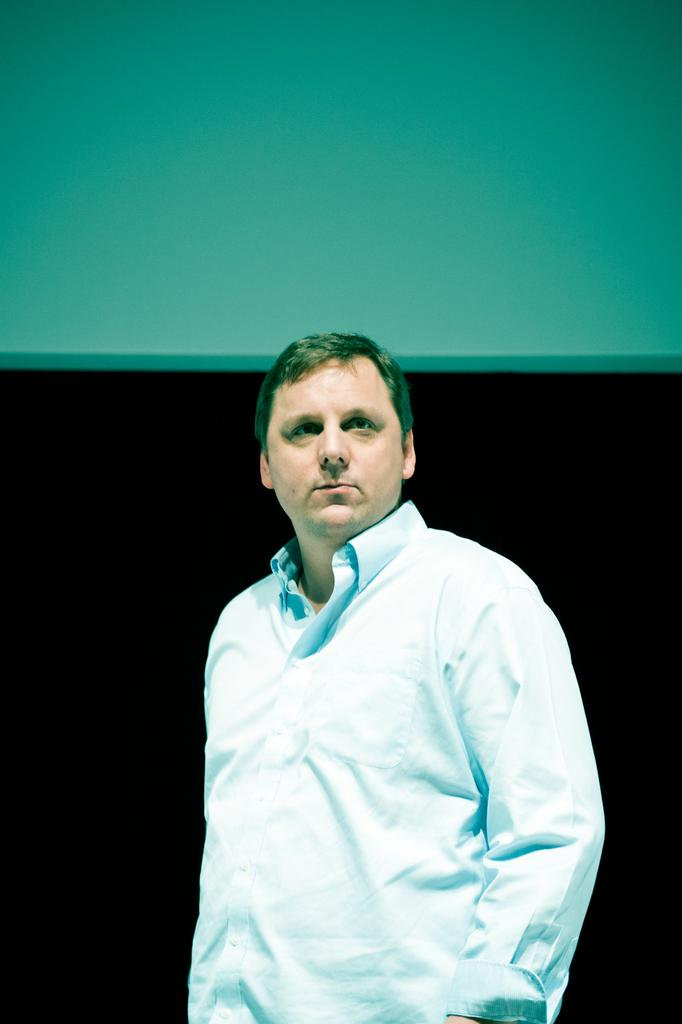What is present in the background of the image? There is a wall in the image. Can you describe the person in the image? There is a person standing in front of the wall. What type of clouds can be seen hanging from the wall in the image? There are no clouds present in the image, and they cannot hang from the wall. 